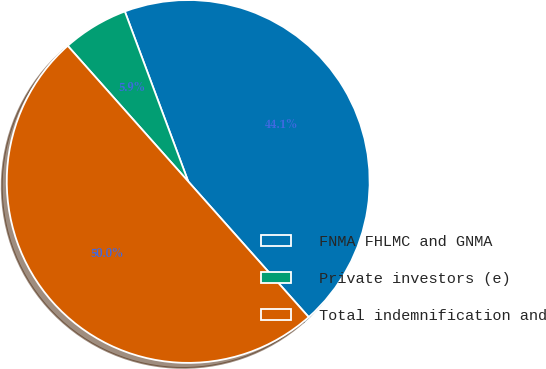<chart> <loc_0><loc_0><loc_500><loc_500><pie_chart><fcel>FNMA FHLMC and GNMA<fcel>Private investors (e)<fcel>Total indemnification and<nl><fcel>44.12%<fcel>5.88%<fcel>50.0%<nl></chart> 